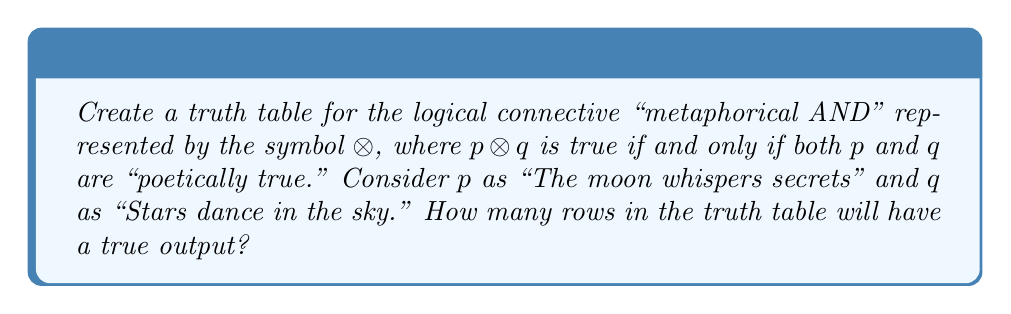Teach me how to tackle this problem. Let's approach this step-by-step:

1) First, we need to construct the truth table for $p \otimes q$. A truth table for two variables has $2^2 = 4$ rows.

2) The truth table will look like this:

   $p$ | $q$ | $p \otimes q$
   ----+-----+--------------
   T   | T   | ?
   T   | F   | ?
   F   | T   | ?
   F   | F   | ?

3) Now, we need to determine the output for each row based on the "metaphorical AND" operation:

   - When both $p$ and $q$ are true, the result is true (both poetic statements are "poetically true").
   - In all other cases, the result is false (if either statement is not "poetically true", the combination is not "poetically true").

4) Filling in the truth table:

   $p$ | $q$ | $p \otimes q$
   ----+-----+--------------
   T   | T   | T
   T   | F   | F
   F   | T   | F
   F   | F   | F

5) To answer the question, we simply need to count the number of rows where the output ($p \otimes q$) is true.

6) There is only one row where $p \otimes q$ is true: when both $p$ and $q$ are true.
Answer: 1 